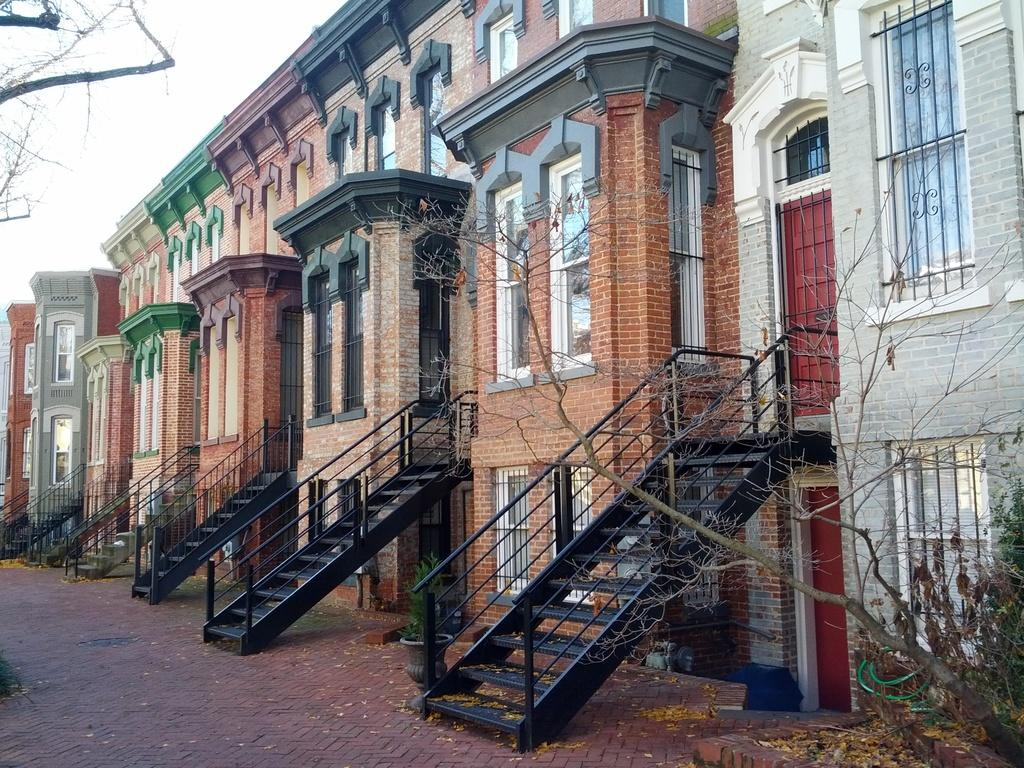What type of structures can be seen in the image? There are buildings in the image. What architectural features are present in the image? There are windows, stairs, railing, and doors visible in the image. What decorative elements can be seen in the image? There are flower pots in the image. What is the condition of the trees in the image? The trees in the image are dry. What is the color of the sky in the image? The sky is white in color. What type of engine is visible in the image? There is no engine present in the image. What time of day is it in the image, based on the hour? The provided facts do not mention the time of day or any hour, so it cannot be determined from the image. 